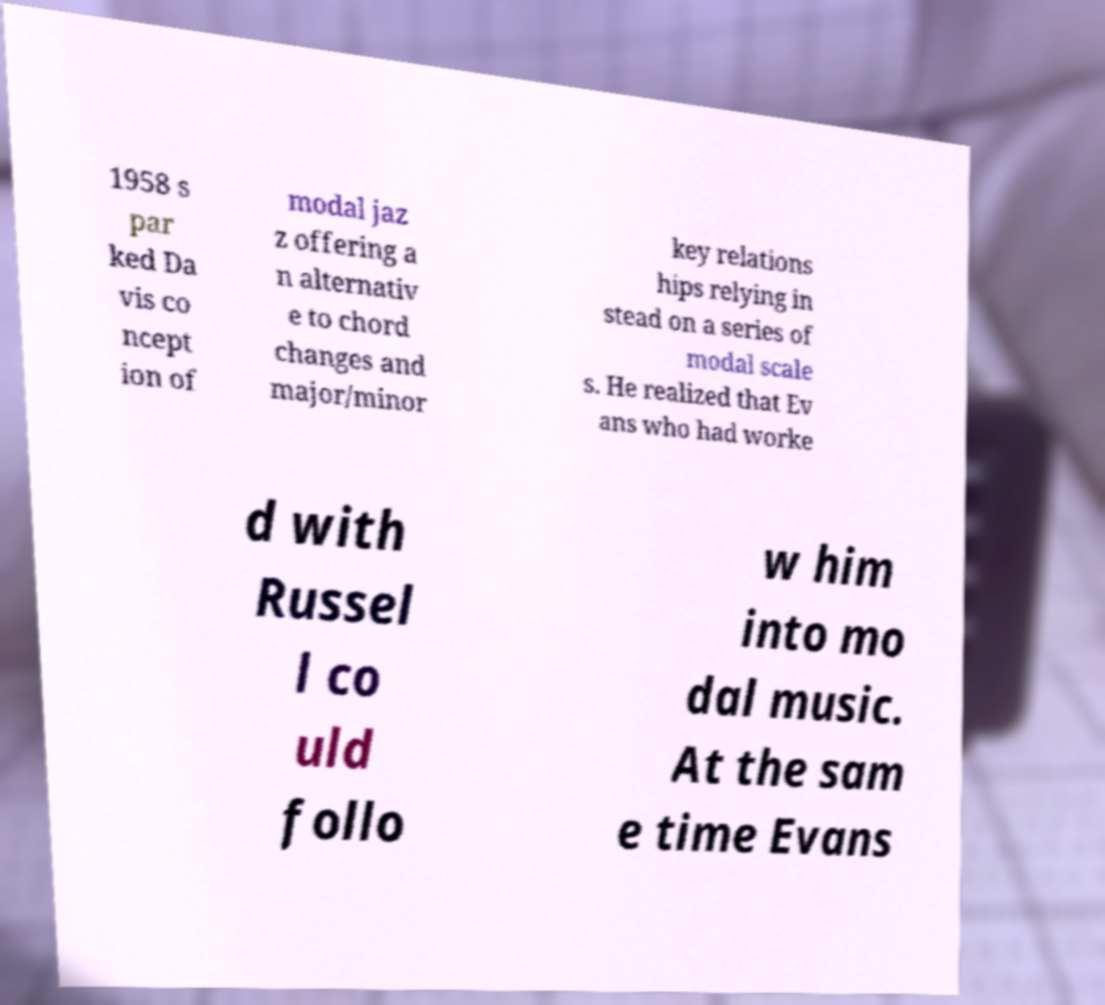Please read and relay the text visible in this image. What does it say? 1958 s par ked Da vis co ncept ion of modal jaz z offering a n alternativ e to chord changes and major/minor key relations hips relying in stead on a series of modal scale s. He realized that Ev ans who had worke d with Russel l co uld follo w him into mo dal music. At the sam e time Evans 